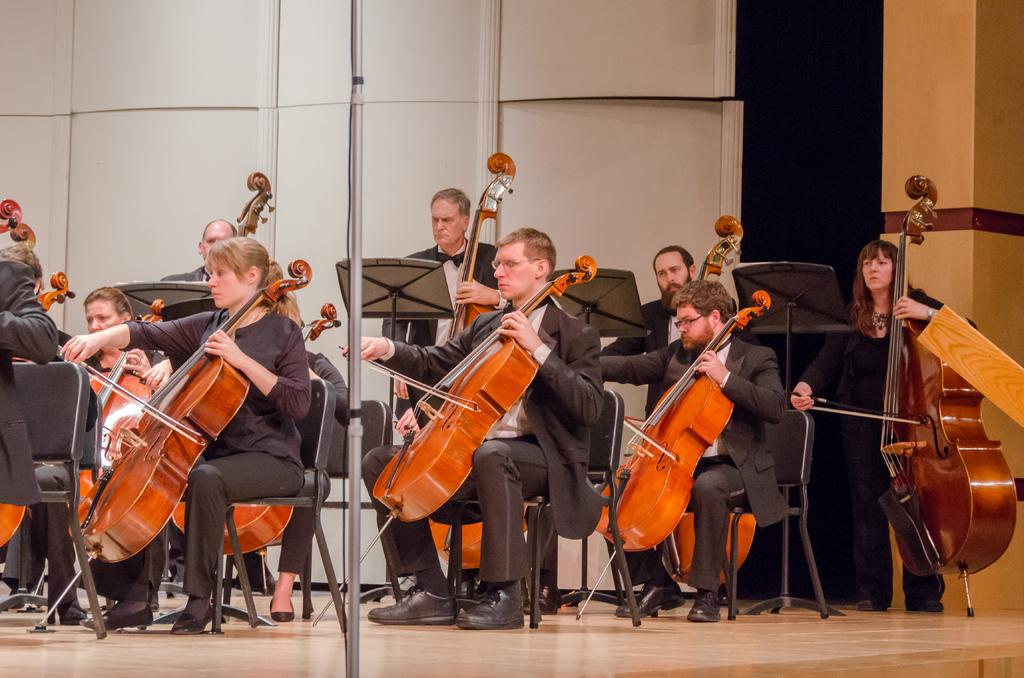What are the people in the image doing? The people in the image are holding musical instruments. What can be seen on the ground in the image? The ground is visible in the image, and there are chairs on it. What other objects can be seen in the image? There are poles and a wall in the image. What type of drum can be seen in the image? There is no drum present in the image. How many geese are visible in the image? There are no geese present in the image. 